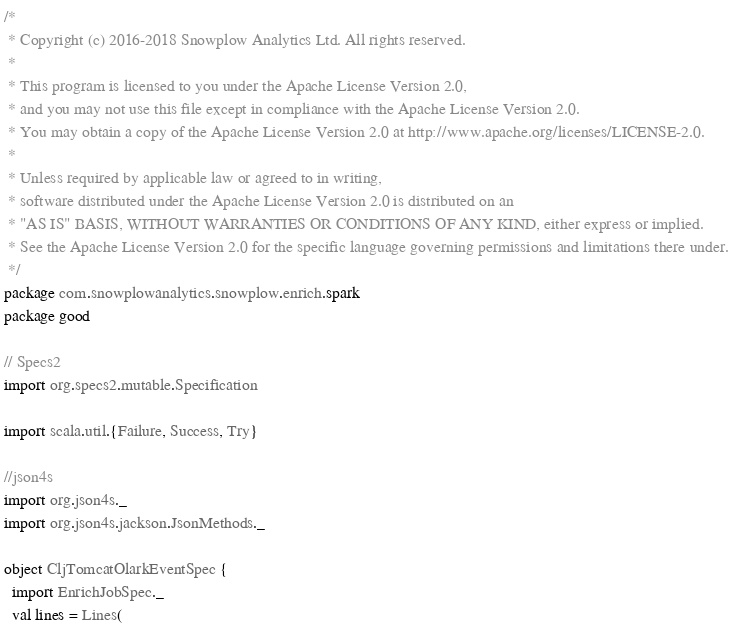Convert code to text. <code><loc_0><loc_0><loc_500><loc_500><_Scala_>/*
 * Copyright (c) 2016-2018 Snowplow Analytics Ltd. All rights reserved.
 *
 * This program is licensed to you under the Apache License Version 2.0,
 * and you may not use this file except in compliance with the Apache License Version 2.0.
 * You may obtain a copy of the Apache License Version 2.0 at http://www.apache.org/licenses/LICENSE-2.0.
 *
 * Unless required by applicable law or agreed to in writing,
 * software distributed under the Apache License Version 2.0 is distributed on an
 * "AS IS" BASIS, WITHOUT WARRANTIES OR CONDITIONS OF ANY KIND, either express or implied.
 * See the Apache License Version 2.0 for the specific language governing permissions and limitations there under.
 */
package com.snowplowanalytics.snowplow.enrich.spark
package good

// Specs2
import org.specs2.mutable.Specification

import scala.util.{Failure, Success, Try}

//json4s
import org.json4s._
import org.json4s.jackson.JsonMethods._

object CljTomcatOlarkEventSpec {
  import EnrichJobSpec._
  val lines = Lines(</code> 